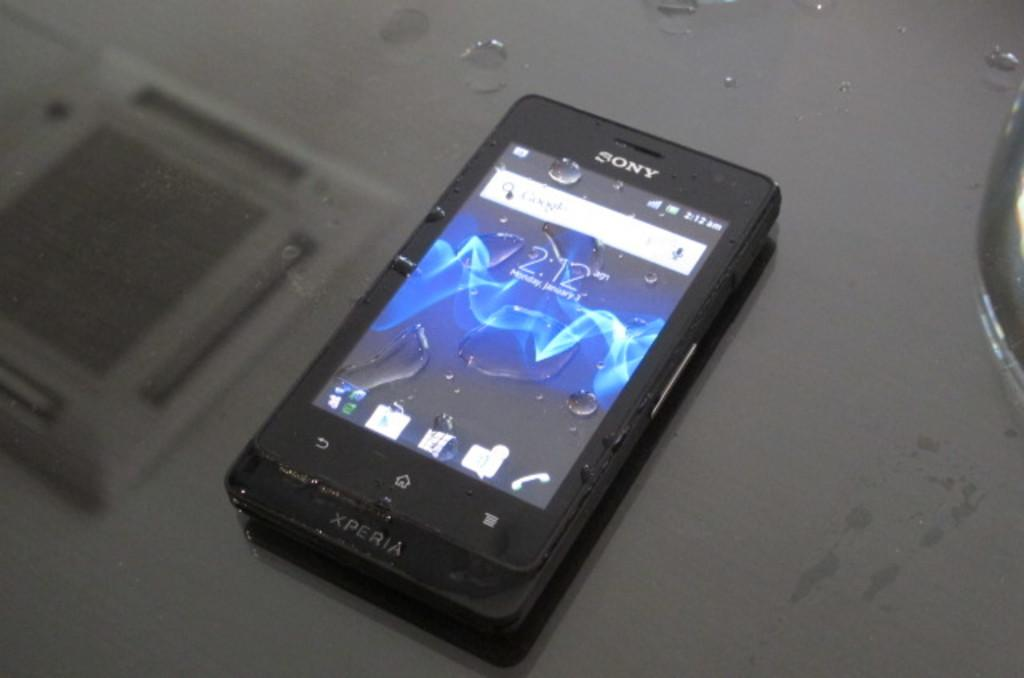<image>
Relay a brief, clear account of the picture shown. A sony smartphone is on a gray table with water drops. 